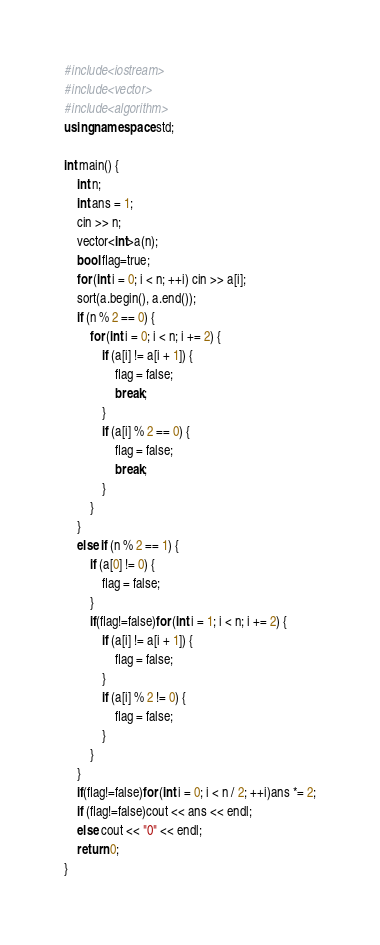<code> <loc_0><loc_0><loc_500><loc_500><_C++_>#include<iostream>
#include<vector>
#include<algorithm>
using namespace std;

int main() {
	int n;
	int ans = 1;
	cin >> n;
	vector<int>a(n);
	bool flag=true;
	for (int i = 0; i < n; ++i) cin >> a[i];
	sort(a.begin(), a.end());
	if (n % 2 == 0) {
		for (int i = 0; i < n; i += 2) {
			if (a[i] != a[i + 1]) {
				flag = false;
				break;
			}
			if (a[i] % 2 == 0) {
				flag = false;
				break;
			}
		}
	}
	else if (n % 2 == 1) {
		if (a[0] != 0) {
			flag = false;
		}
		if(flag!=false)for (int i = 1; i < n; i += 2) {
			if (a[i] != a[i + 1]) {
				flag = false;
			}
			if (a[i] % 2 != 0) {
				flag = false;
			}
		}
	}
	if(flag!=false)for (int i = 0; i < n / 2; ++i)ans *= 2;
	if (flag!=false)cout << ans << endl;
	else cout << "0" << endl;
	return 0;
}</code> 